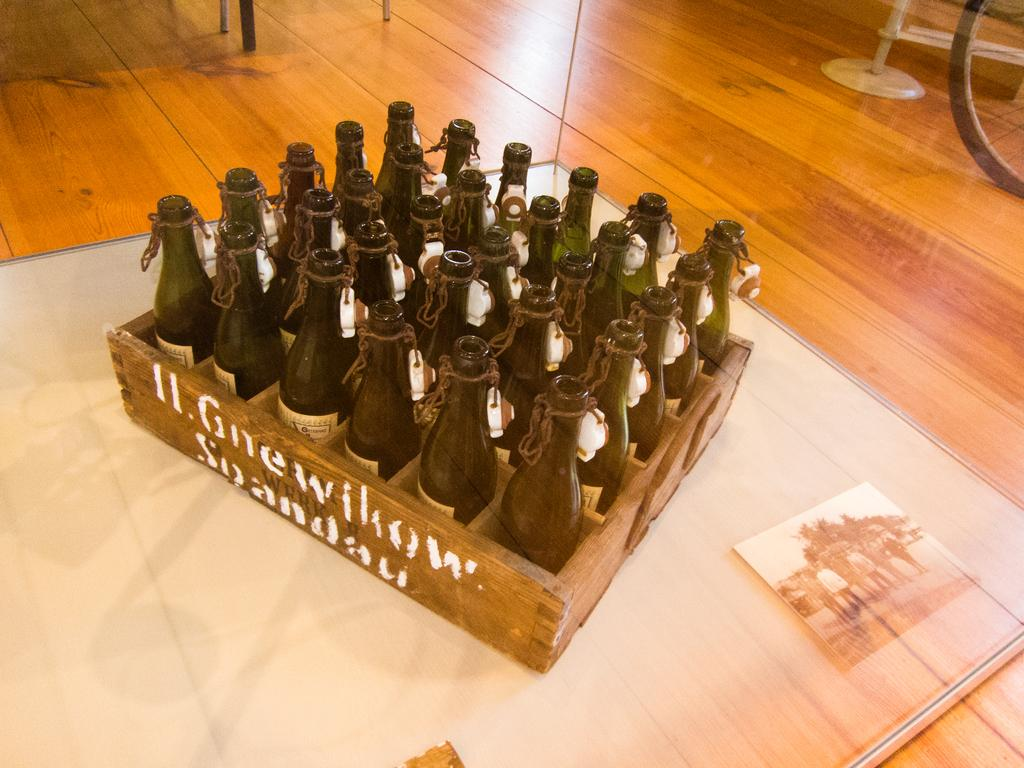<image>
Describe the image concisely. A lot of bottles are in a box with Gnewikow in white letters on the side of the box. 